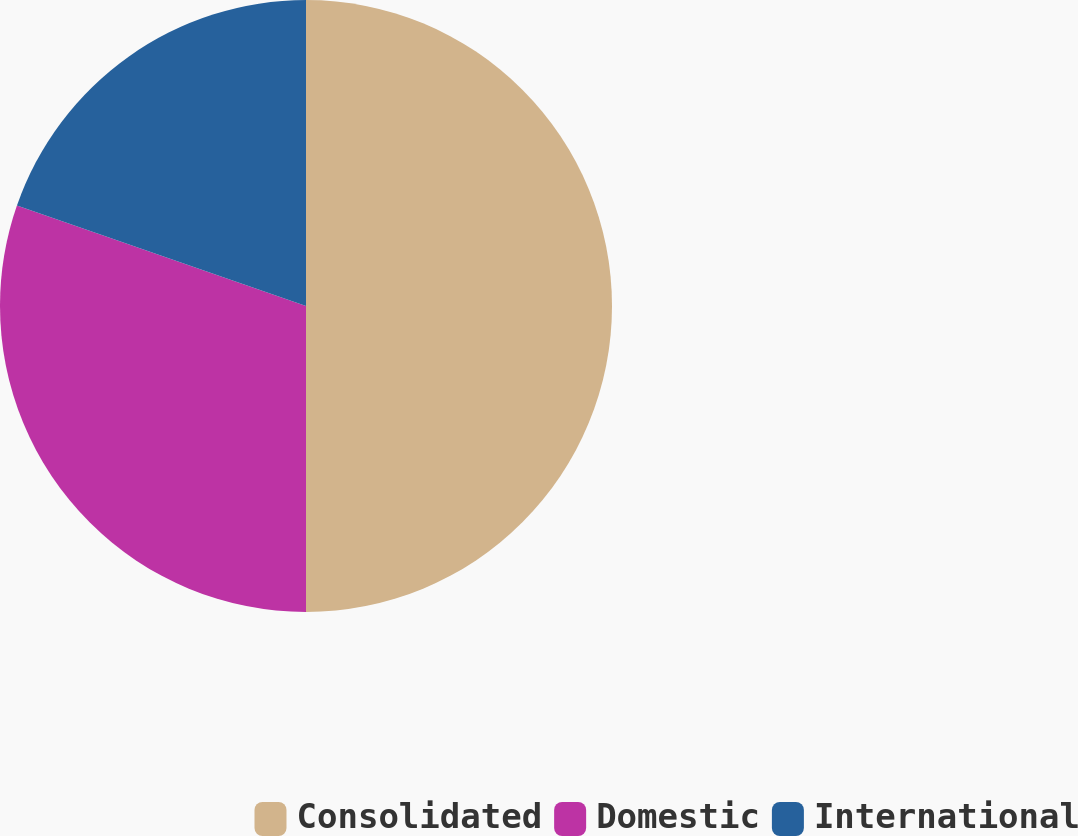Convert chart to OTSL. <chart><loc_0><loc_0><loc_500><loc_500><pie_chart><fcel>Consolidated<fcel>Domestic<fcel>International<nl><fcel>50.0%<fcel>30.32%<fcel>19.68%<nl></chart> 